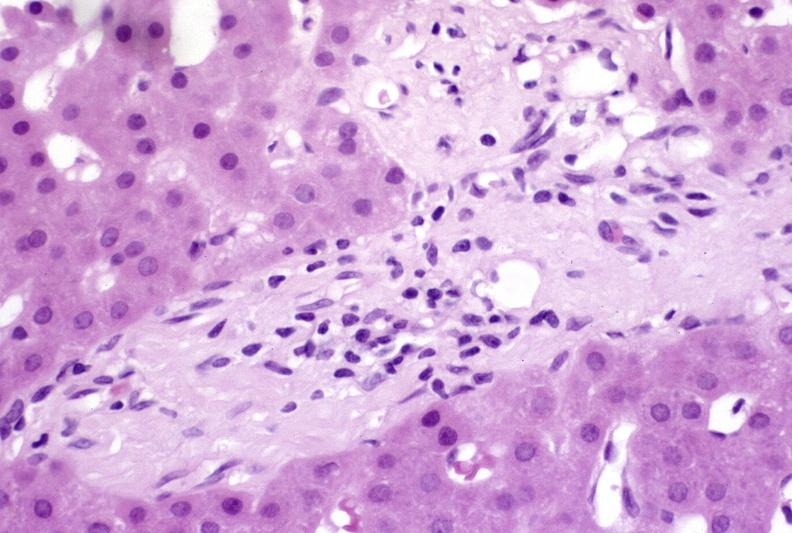does siamese twins show ductopenia?
Answer the question using a single word or phrase. No 